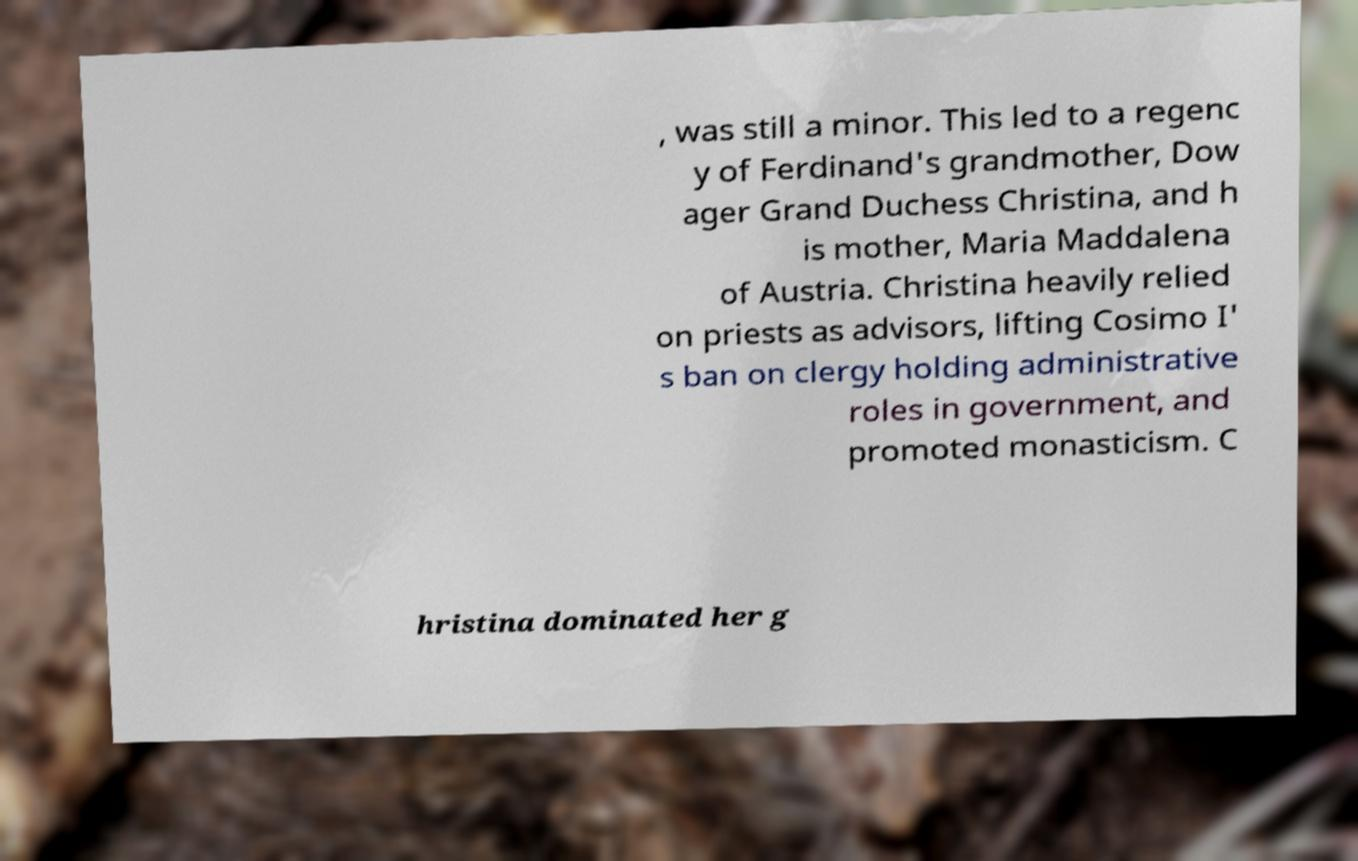There's text embedded in this image that I need extracted. Can you transcribe it verbatim? , was still a minor. This led to a regenc y of Ferdinand's grandmother, Dow ager Grand Duchess Christina, and h is mother, Maria Maddalena of Austria. Christina heavily relied on priests as advisors, lifting Cosimo I' s ban on clergy holding administrative roles in government, and promoted monasticism. C hristina dominated her g 